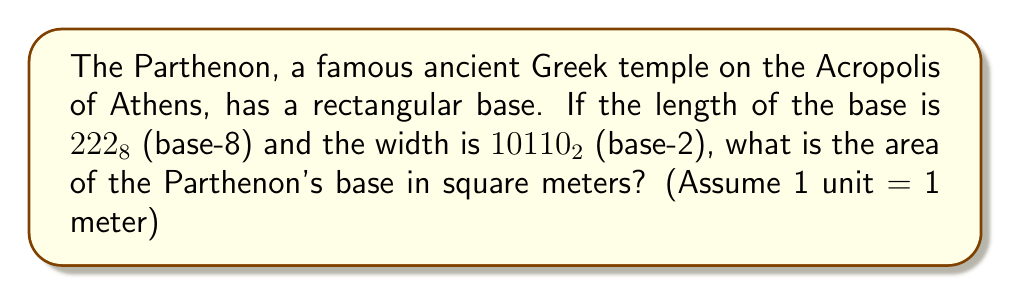Give your solution to this math problem. To solve this problem, we need to follow these steps:

1. Convert the length from octal to decimal:
   $222_8 = 2 \times 8^2 + 2 \times 8^1 + 2 \times 8^0 = 128 + 16 + 2 = 146_{10}$

2. Convert the width from binary to decimal:
   $10110_2 = 1 \times 2^4 + 0 \times 2^3 + 1 \times 2^2 + 1 \times 2^1 + 0 \times 2^0 = 16 + 0 + 4 + 2 + 0 = 22_{10}$

3. Calculate the area by multiplying the length and width:
   $A = l \times w = 146 \times 22 = 3212$ square meters

Therefore, the area of the Parthenon's base is 3212 square meters.
Answer: 3212 square meters 